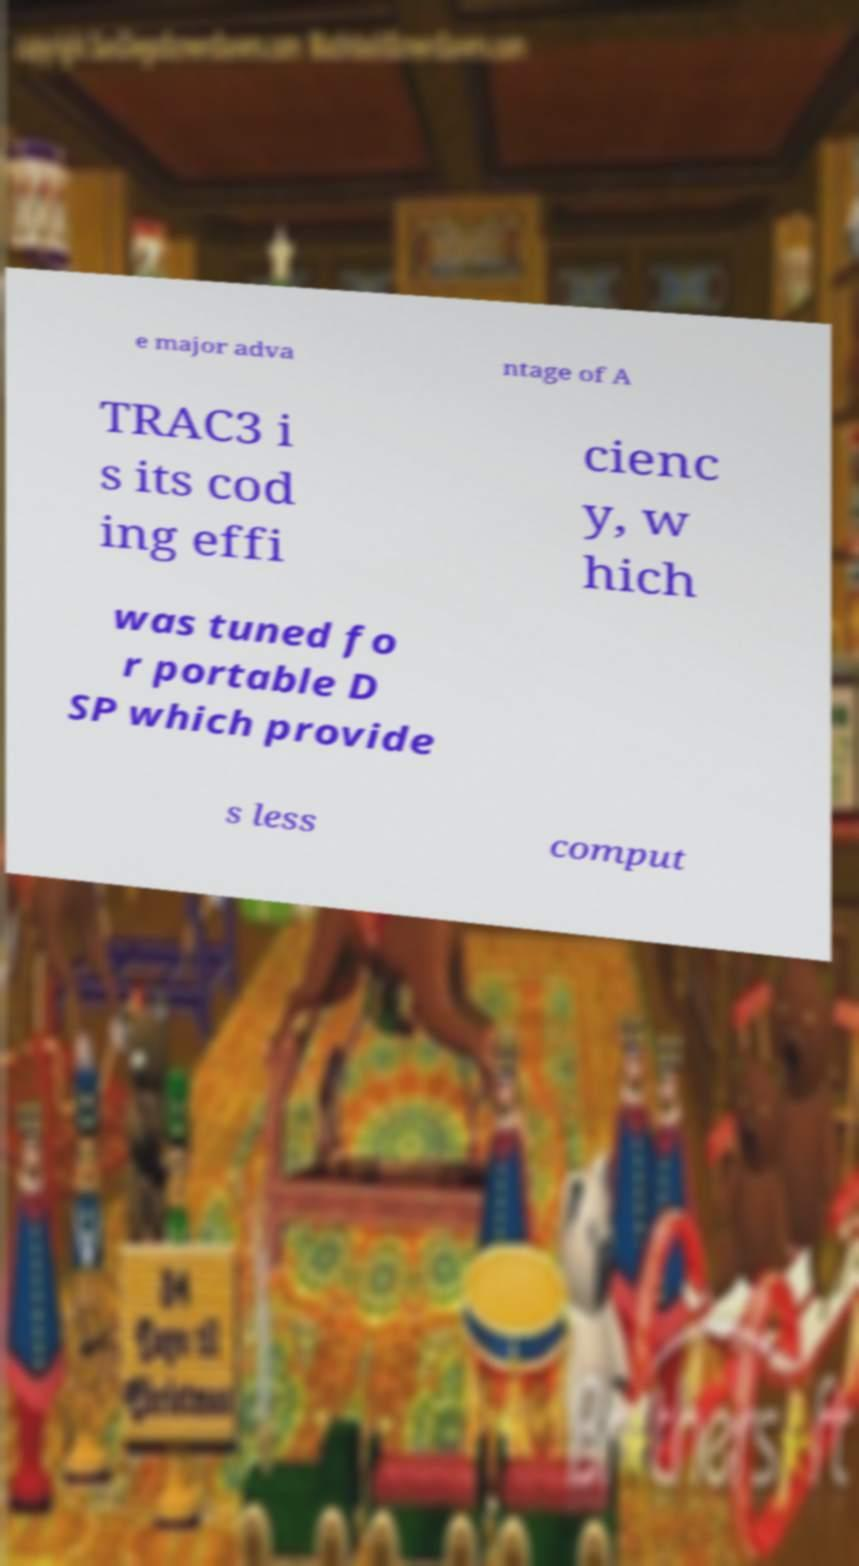There's text embedded in this image that I need extracted. Can you transcribe it verbatim? e major adva ntage of A TRAC3 i s its cod ing effi cienc y, w hich was tuned fo r portable D SP which provide s less comput 